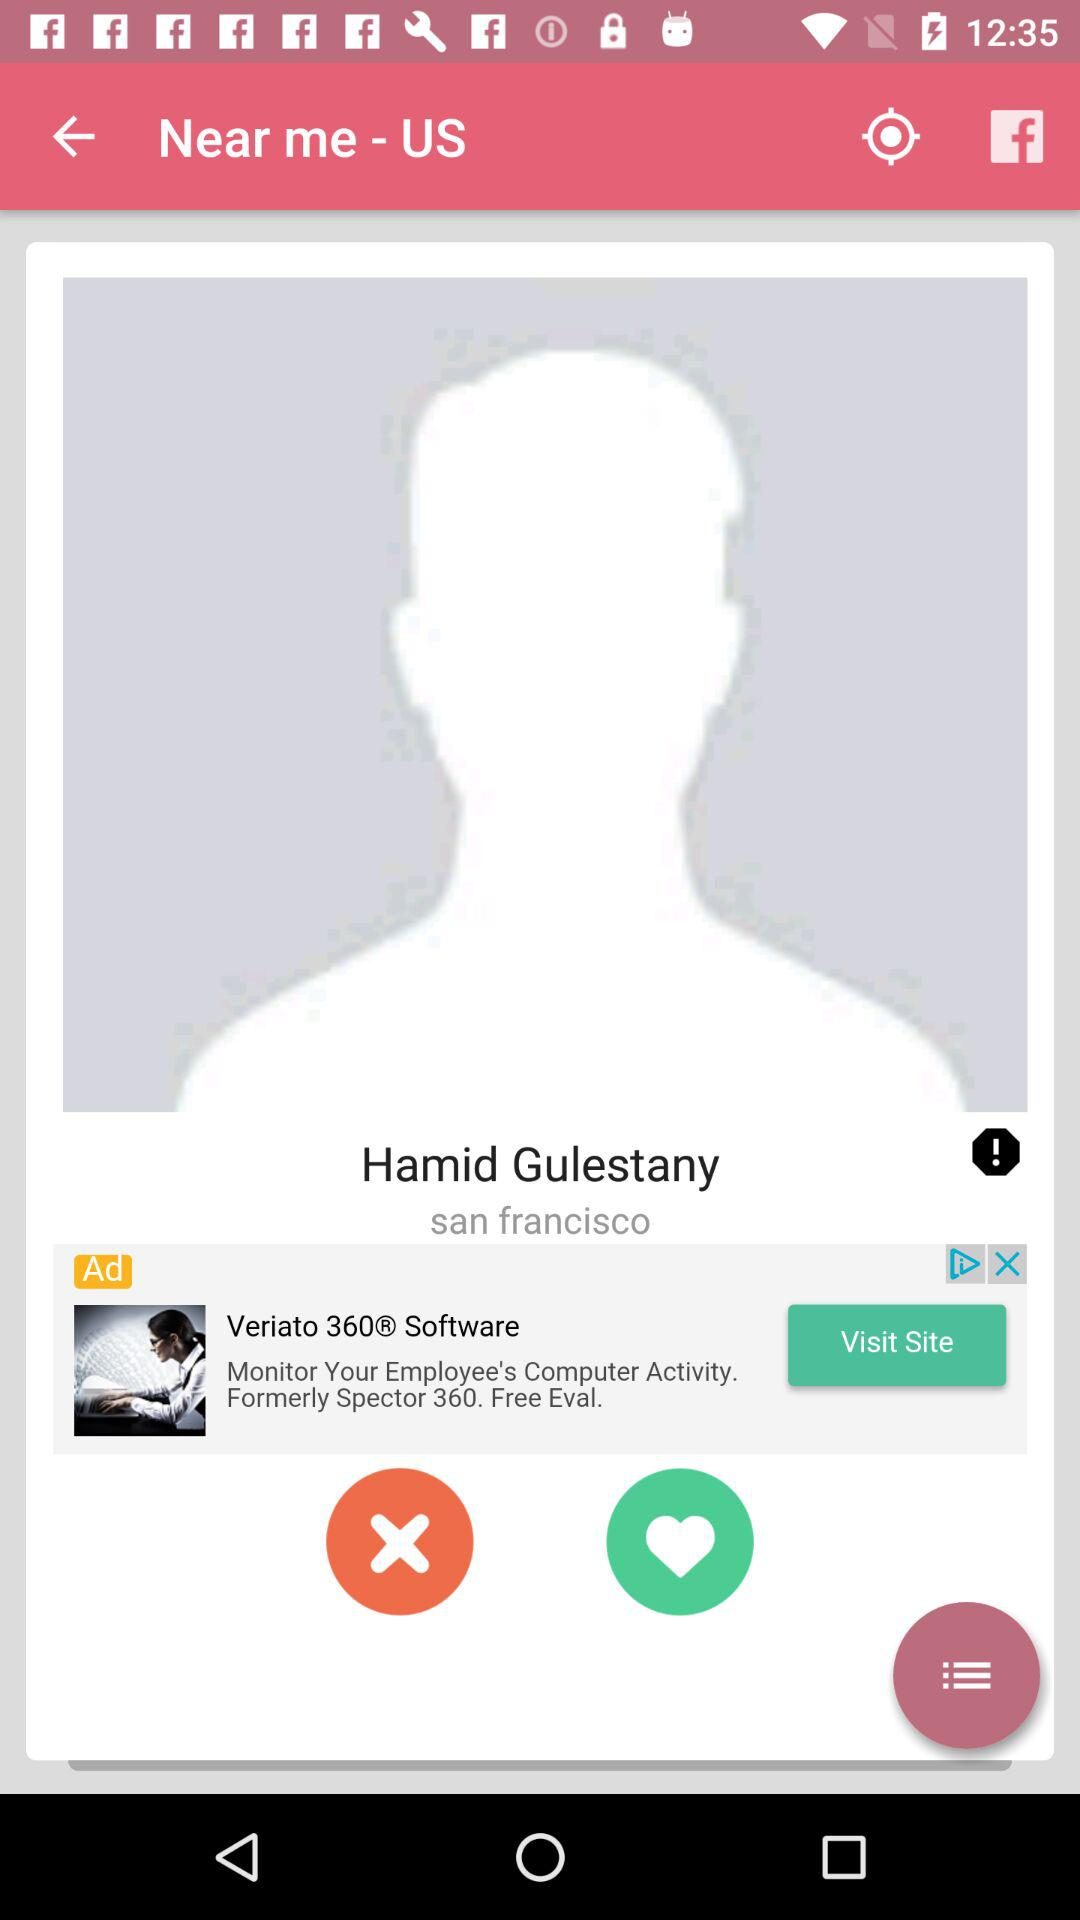What is the user name? The user name is Hamid Gulestany. 